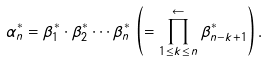<formula> <loc_0><loc_0><loc_500><loc_500>{ \alpha ^ { * } _ { n } } = { \beta ^ { * } _ { 1 } } \cdot { \beta ^ { * } _ { 2 } } \cdots { \beta ^ { * } _ { n } } \, \left ( = \prod _ { 1 \leq k \leq n } ^ { \gets } { \beta ^ { * } _ { n - k + 1 } } \right ) .</formula> 